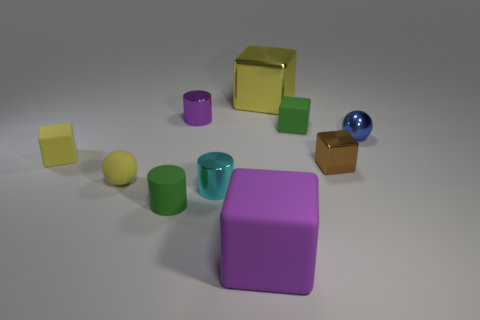How would you describe the arrangement of these objects? The objects appear to be arranged in a somewhat scattered and random pattern across a flat surface. There seems to be no precise alignment or order, which gives the scene a casual and unstructured look. 